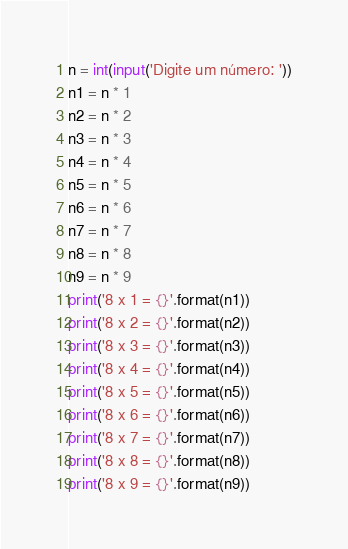Convert code to text. <code><loc_0><loc_0><loc_500><loc_500><_Python_>n = int(input('Digite um número: '))
n1 = n * 1
n2 = n * 2
n3 = n * 3
n4 = n * 4
n5 = n * 5
n6 = n * 6
n7 = n * 7
n8 = n * 8
n9 = n * 9
print('8 x 1 = {}'.format(n1))
print('8 x 2 = {}'.format(n2))
print('8 x 3 = {}'.format(n3))
print('8 x 4 = {}'.format(n4))
print('8 x 5 = {}'.format(n5))
print('8 x 6 = {}'.format(n6))
print('8 x 7 = {}'.format(n7))
print('8 x 8 = {}'.format(n8))
print('8 x 9 = {}'.format(n9))
</code> 